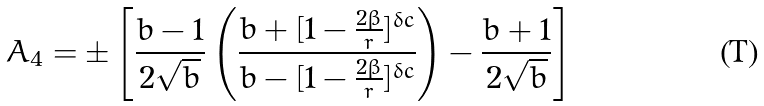Convert formula to latex. <formula><loc_0><loc_0><loc_500><loc_500>A _ { 4 } = \pm \left [ \frac { b - 1 } { 2 \sqrt { b } } \left ( \frac { b + [ 1 - \frac { 2 \beta } { r } ] ^ { \delta c } } { b - [ 1 - \frac { 2 \beta } { r } ] ^ { \delta c } } \right ) - \frac { b + 1 } { 2 \sqrt { b } } \right ]</formula> 